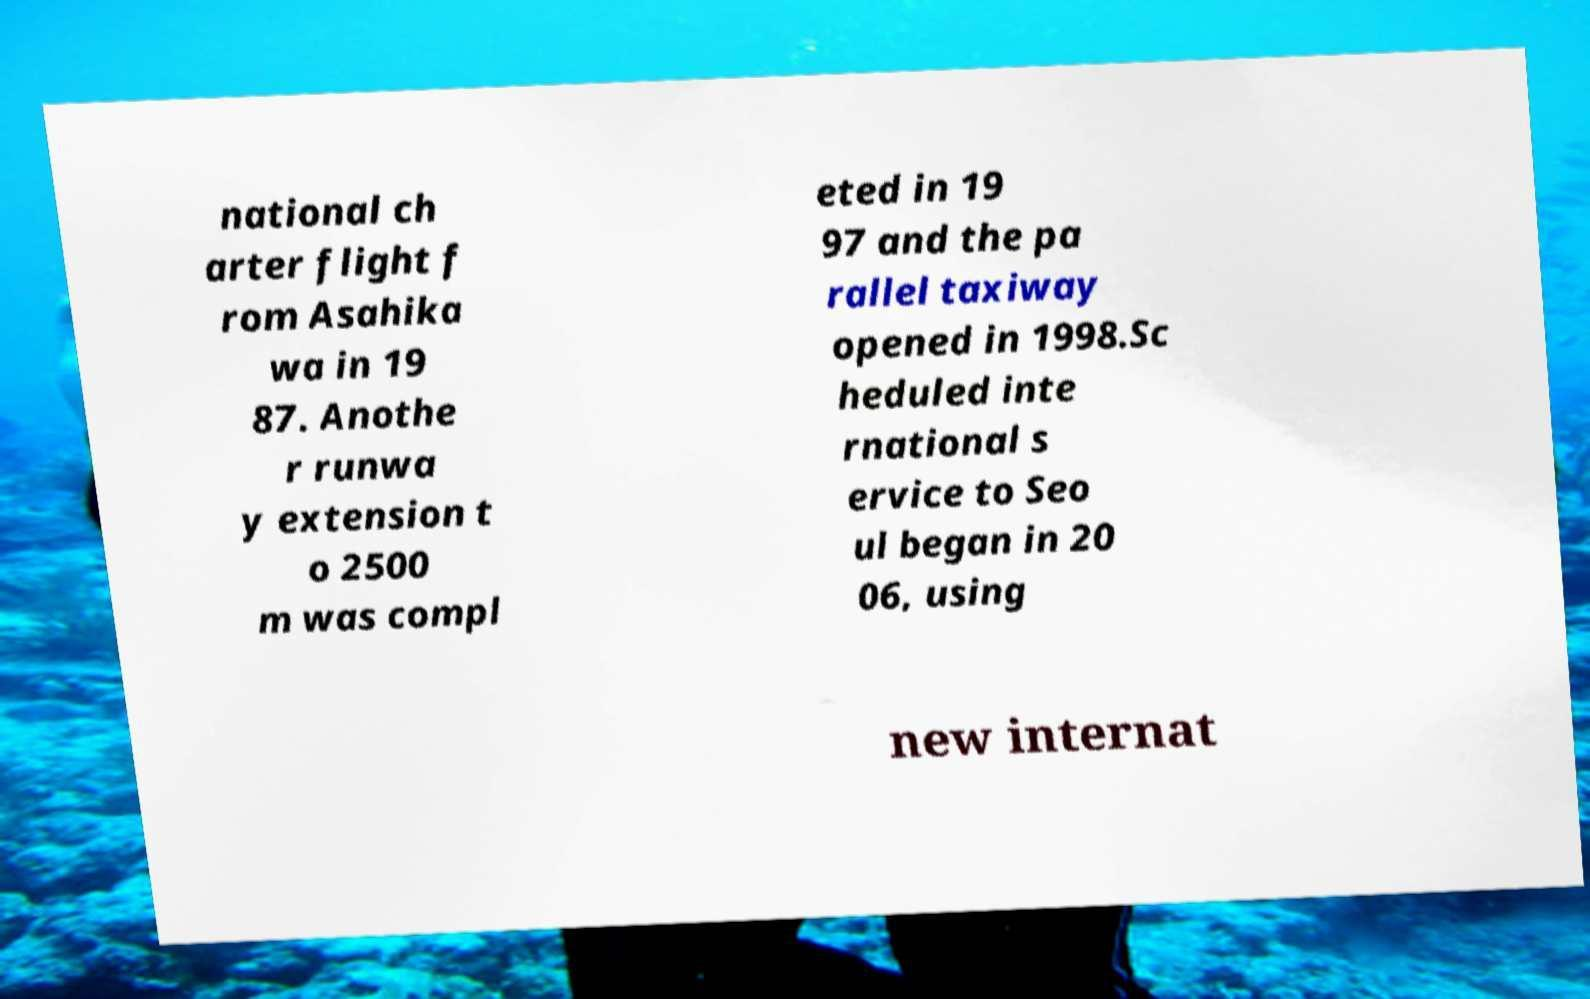Can you accurately transcribe the text from the provided image for me? national ch arter flight f rom Asahika wa in 19 87. Anothe r runwa y extension t o 2500 m was compl eted in 19 97 and the pa rallel taxiway opened in 1998.Sc heduled inte rnational s ervice to Seo ul began in 20 06, using new internat 